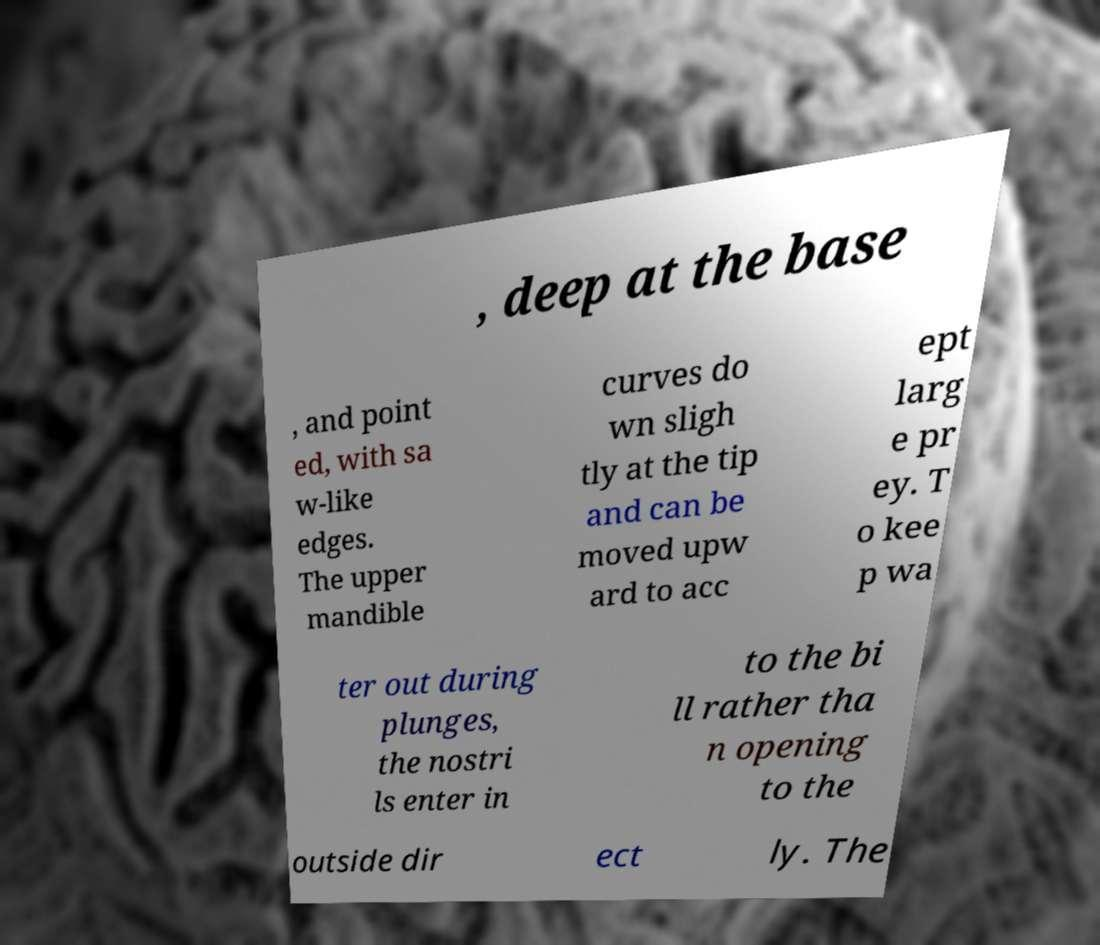I need the written content from this picture converted into text. Can you do that? , deep at the base , and point ed, with sa w-like edges. The upper mandible curves do wn sligh tly at the tip and can be moved upw ard to acc ept larg e pr ey. T o kee p wa ter out during plunges, the nostri ls enter in to the bi ll rather tha n opening to the outside dir ect ly. The 